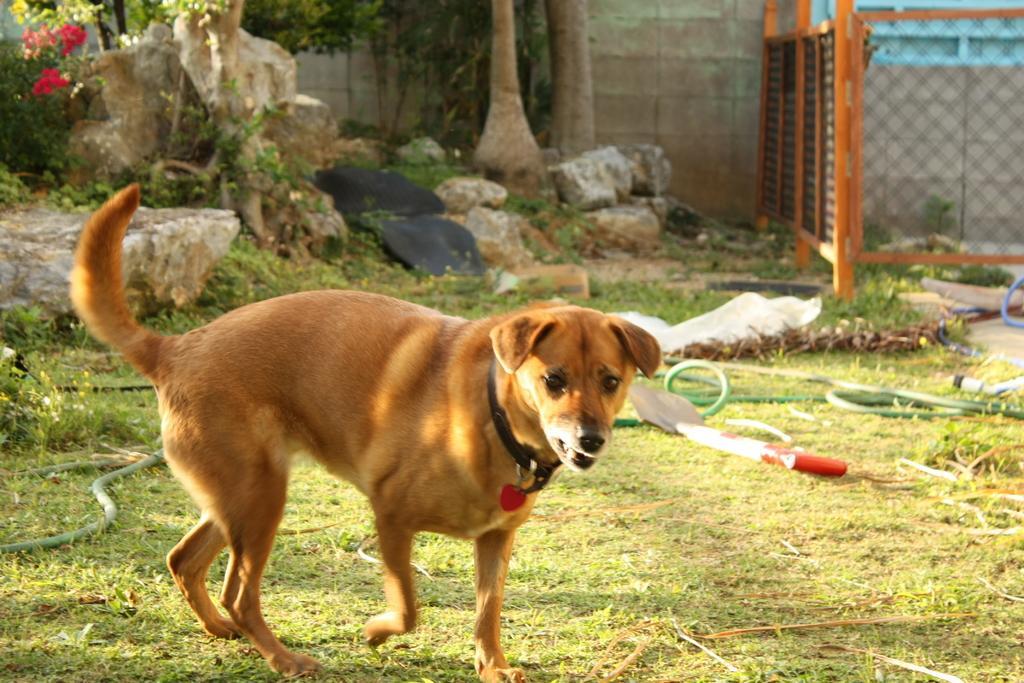Please provide a concise description of this image. There is a brown dog with a collar. On the ground there is grass, pipe. In the back there are rocks, trees. Also there is a wooden wall. 